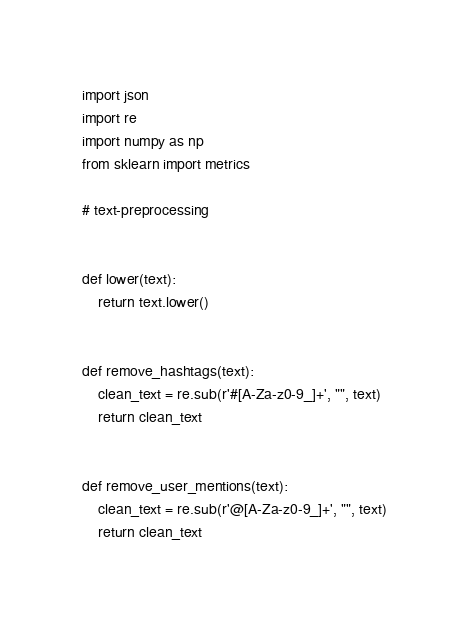Convert code to text. <code><loc_0><loc_0><loc_500><loc_500><_Python_>import json
import re
import numpy as np
from sklearn import metrics

# text-preprocessing


def lower(text):
    return text.lower()


def remove_hashtags(text):
    clean_text = re.sub(r'#[A-Za-z0-9_]+', "", text)
    return clean_text


def remove_user_mentions(text):
    clean_text = re.sub(r'@[A-Za-z0-9_]+', "", text)
    return clean_text

</code> 